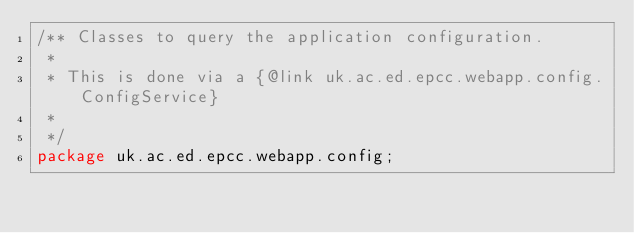Convert code to text. <code><loc_0><loc_0><loc_500><loc_500><_Java_>/** Classes to query the application configuration.
 * 
 * This is done via a {@link uk.ac.ed.epcc.webapp.config.ConfigService}
 * 
 */
package uk.ac.ed.epcc.webapp.config;</code> 